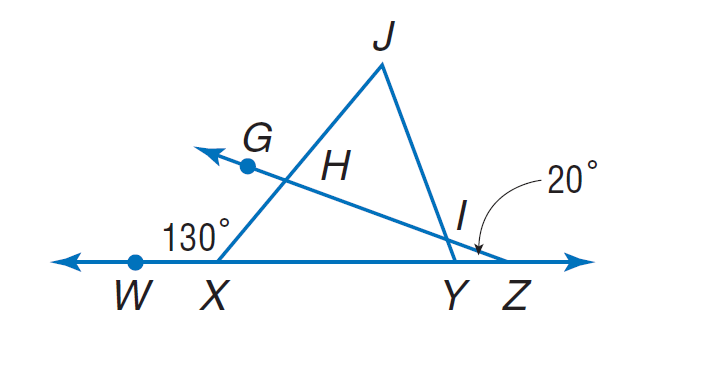Answer the mathemtical geometry problem and directly provide the correct option letter.
Question: If \frac { I J } { X J } = \frac { H J } { Y J }, m \angle W X J = 130, and m \angle W Z G = 20, find m \angle J H G.
Choices: A: 100 B: 110 C: 120 D: 130 B 